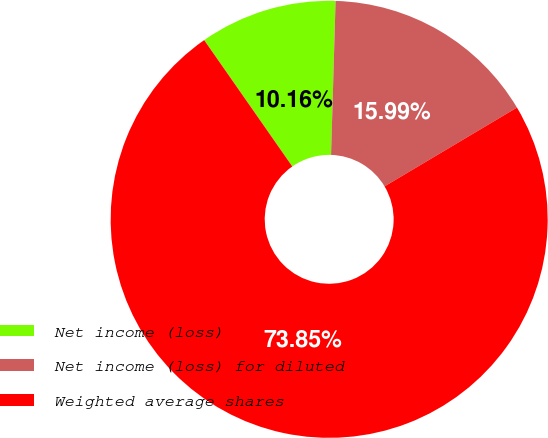Convert chart to OTSL. <chart><loc_0><loc_0><loc_500><loc_500><pie_chart><fcel>Net income (loss)<fcel>Net income (loss) for diluted<fcel>Weighted average shares<nl><fcel>10.16%<fcel>15.99%<fcel>73.85%<nl></chart> 